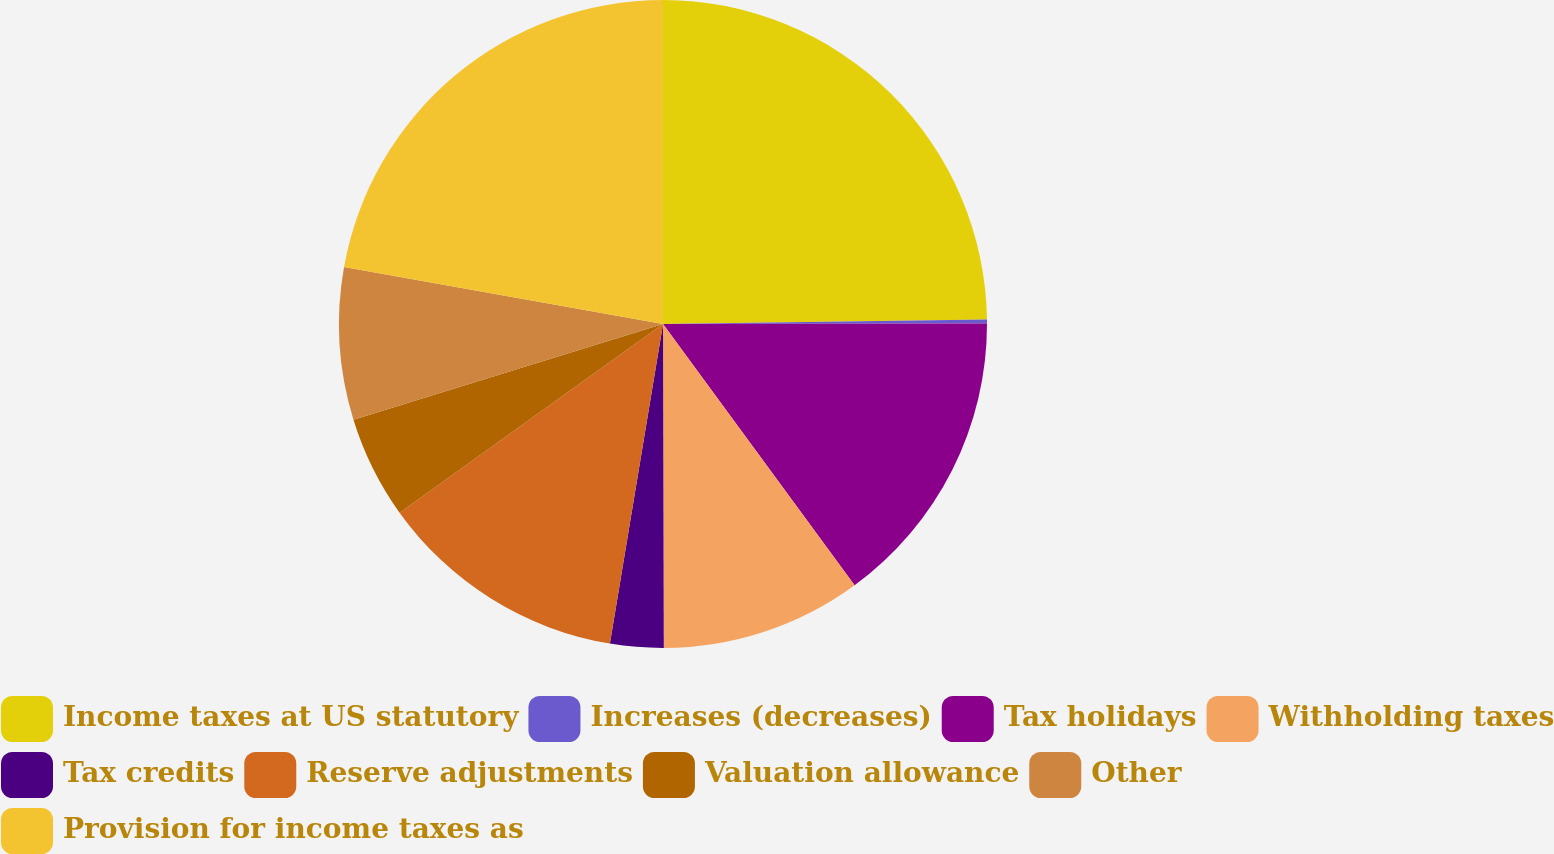<chart> <loc_0><loc_0><loc_500><loc_500><pie_chart><fcel>Income taxes at US statutory<fcel>Increases (decreases)<fcel>Tax holidays<fcel>Withholding taxes<fcel>Tax credits<fcel>Reserve adjustments<fcel>Valuation allowance<fcel>Other<fcel>Provision for income taxes as<nl><fcel>24.78%<fcel>0.2%<fcel>14.95%<fcel>10.03%<fcel>2.66%<fcel>12.49%<fcel>5.12%<fcel>7.58%<fcel>22.19%<nl></chart> 